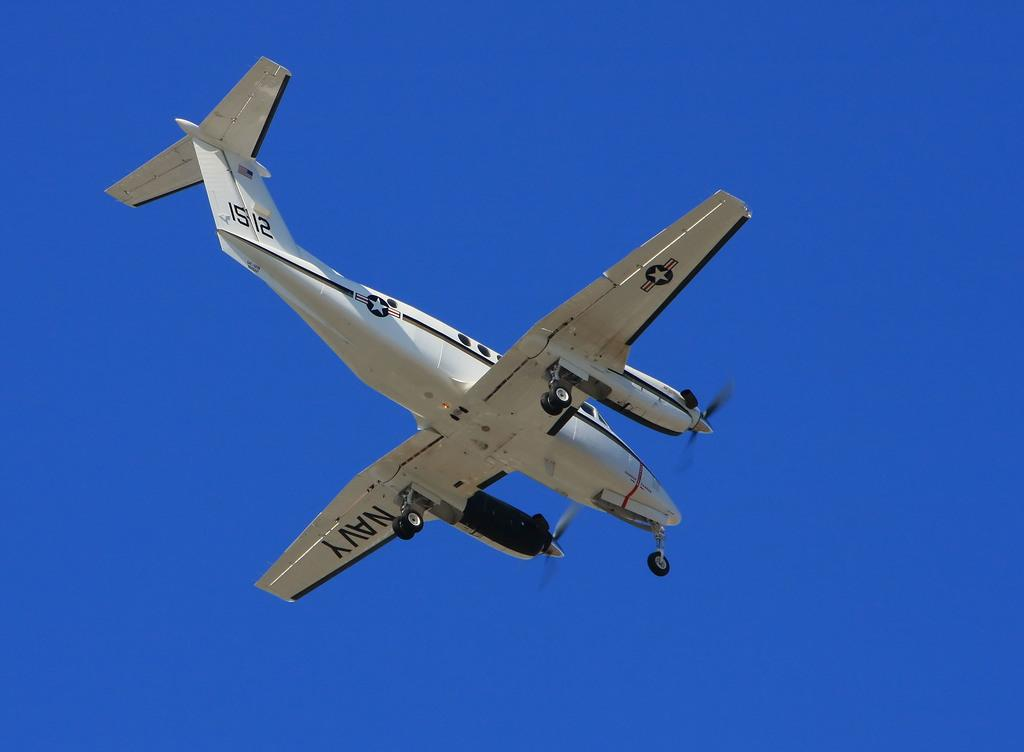What is the main subject of the image? The main subject of the image is an aeroplane. Where is the aeroplane located in the image? The aeroplane is in the middle of the image. What color is the sky in the background of the image? The sky is blue in the background of the image. What book is the aeroplane reading in the image? There is no book or reading activity depicted in the image; it features an aeroplane in the sky. What type of poison is present in the image? There is no poison present in the image; it only shows an aeroplane in the sky with a blue background. 